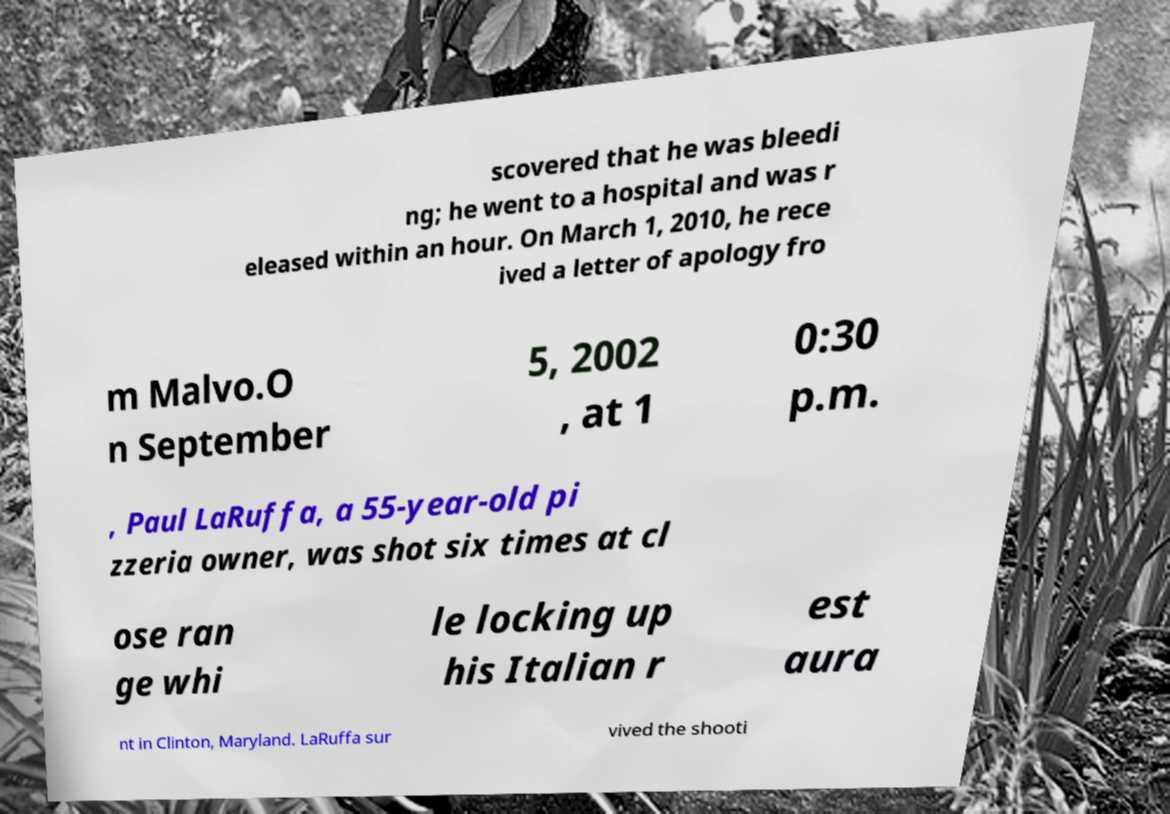I need the written content from this picture converted into text. Can you do that? scovered that he was bleedi ng; he went to a hospital and was r eleased within an hour. On March 1, 2010, he rece ived a letter of apology fro m Malvo.O n September 5, 2002 , at 1 0:30 p.m. , Paul LaRuffa, a 55-year-old pi zzeria owner, was shot six times at cl ose ran ge whi le locking up his Italian r est aura nt in Clinton, Maryland. LaRuffa sur vived the shooti 